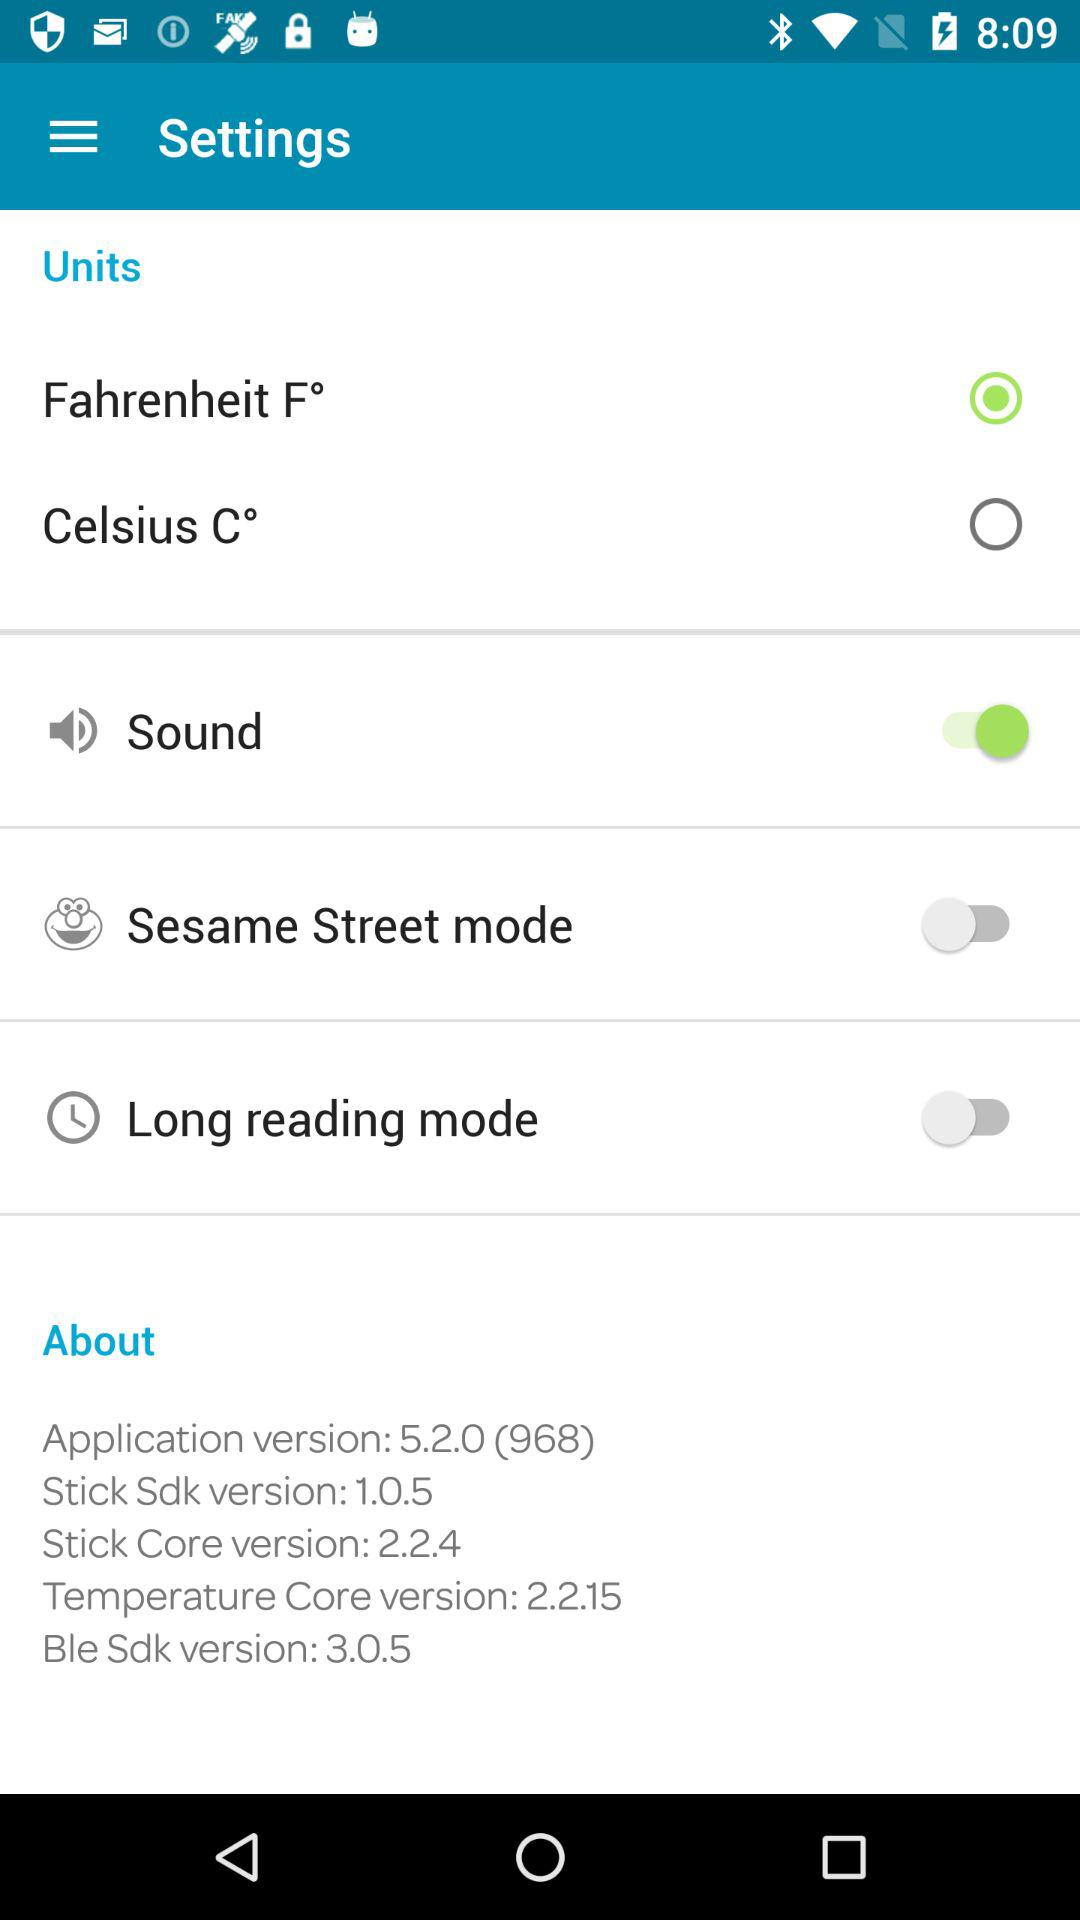What unit of temperature is selected? The unit of temperature selected is Fahrenheit (F°). 